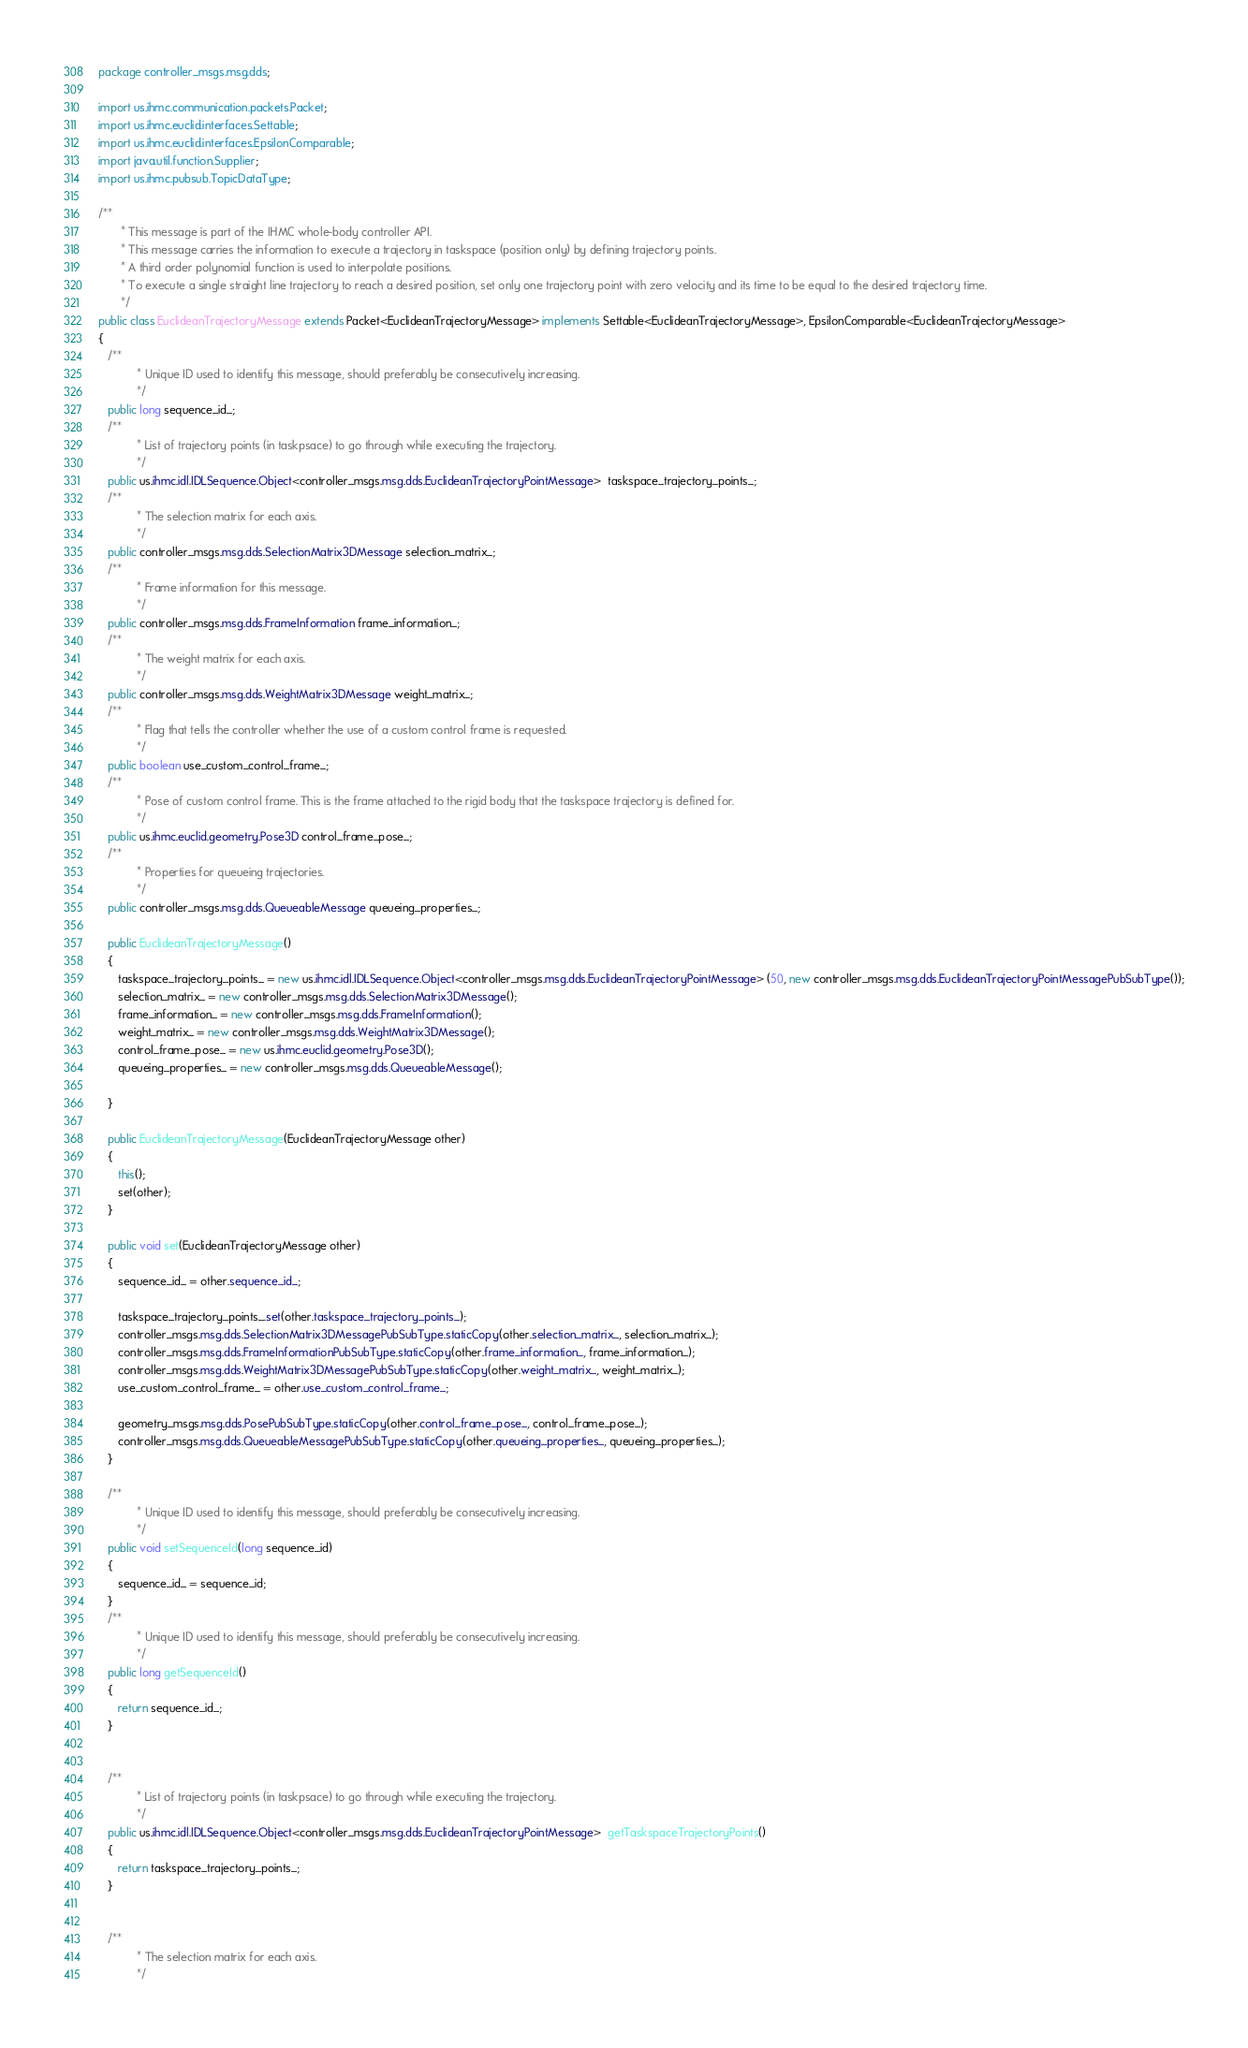<code> <loc_0><loc_0><loc_500><loc_500><_Java_>package controller_msgs.msg.dds;

import us.ihmc.communication.packets.Packet;
import us.ihmc.euclid.interfaces.Settable;
import us.ihmc.euclid.interfaces.EpsilonComparable;
import java.util.function.Supplier;
import us.ihmc.pubsub.TopicDataType;

/**
       * This message is part of the IHMC whole-body controller API.
       * This message carries the information to execute a trajectory in taskspace (position only) by defining trajectory points.
       * A third order polynomial function is used to interpolate positions.
       * To execute a single straight line trajectory to reach a desired position, set only one trajectory point with zero velocity and its time to be equal to the desired trajectory time.
       */
public class EuclideanTrajectoryMessage extends Packet<EuclideanTrajectoryMessage> implements Settable<EuclideanTrajectoryMessage>, EpsilonComparable<EuclideanTrajectoryMessage>
{
   /**
            * Unique ID used to identify this message, should preferably be consecutively increasing.
            */
   public long sequence_id_;
   /**
            * List of trajectory points (in taskpsace) to go through while executing the trajectory.
            */
   public us.ihmc.idl.IDLSequence.Object<controller_msgs.msg.dds.EuclideanTrajectoryPointMessage>  taskspace_trajectory_points_;
   /**
            * The selection matrix for each axis.
            */
   public controller_msgs.msg.dds.SelectionMatrix3DMessage selection_matrix_;
   /**
            * Frame information for this message.
            */
   public controller_msgs.msg.dds.FrameInformation frame_information_;
   /**
            * The weight matrix for each axis.
            */
   public controller_msgs.msg.dds.WeightMatrix3DMessage weight_matrix_;
   /**
            * Flag that tells the controller whether the use of a custom control frame is requested.
            */
   public boolean use_custom_control_frame_;
   /**
            * Pose of custom control frame. This is the frame attached to the rigid body that the taskspace trajectory is defined for.
            */
   public us.ihmc.euclid.geometry.Pose3D control_frame_pose_;
   /**
            * Properties for queueing trajectories.
            */
   public controller_msgs.msg.dds.QueueableMessage queueing_properties_;

   public EuclideanTrajectoryMessage()
   {
      taskspace_trajectory_points_ = new us.ihmc.idl.IDLSequence.Object<controller_msgs.msg.dds.EuclideanTrajectoryPointMessage> (50, new controller_msgs.msg.dds.EuclideanTrajectoryPointMessagePubSubType());
      selection_matrix_ = new controller_msgs.msg.dds.SelectionMatrix3DMessage();
      frame_information_ = new controller_msgs.msg.dds.FrameInformation();
      weight_matrix_ = new controller_msgs.msg.dds.WeightMatrix3DMessage();
      control_frame_pose_ = new us.ihmc.euclid.geometry.Pose3D();
      queueing_properties_ = new controller_msgs.msg.dds.QueueableMessage();

   }

   public EuclideanTrajectoryMessage(EuclideanTrajectoryMessage other)
   {
      this();
      set(other);
   }

   public void set(EuclideanTrajectoryMessage other)
   {
      sequence_id_ = other.sequence_id_;

      taskspace_trajectory_points_.set(other.taskspace_trajectory_points_);
      controller_msgs.msg.dds.SelectionMatrix3DMessagePubSubType.staticCopy(other.selection_matrix_, selection_matrix_);
      controller_msgs.msg.dds.FrameInformationPubSubType.staticCopy(other.frame_information_, frame_information_);
      controller_msgs.msg.dds.WeightMatrix3DMessagePubSubType.staticCopy(other.weight_matrix_, weight_matrix_);
      use_custom_control_frame_ = other.use_custom_control_frame_;

      geometry_msgs.msg.dds.PosePubSubType.staticCopy(other.control_frame_pose_, control_frame_pose_);
      controller_msgs.msg.dds.QueueableMessagePubSubType.staticCopy(other.queueing_properties_, queueing_properties_);
   }

   /**
            * Unique ID used to identify this message, should preferably be consecutively increasing.
            */
   public void setSequenceId(long sequence_id)
   {
      sequence_id_ = sequence_id;
   }
   /**
            * Unique ID used to identify this message, should preferably be consecutively increasing.
            */
   public long getSequenceId()
   {
      return sequence_id_;
   }


   /**
            * List of trajectory points (in taskpsace) to go through while executing the trajectory.
            */
   public us.ihmc.idl.IDLSequence.Object<controller_msgs.msg.dds.EuclideanTrajectoryPointMessage>  getTaskspaceTrajectoryPoints()
   {
      return taskspace_trajectory_points_;
   }


   /**
            * The selection matrix for each axis.
            */</code> 